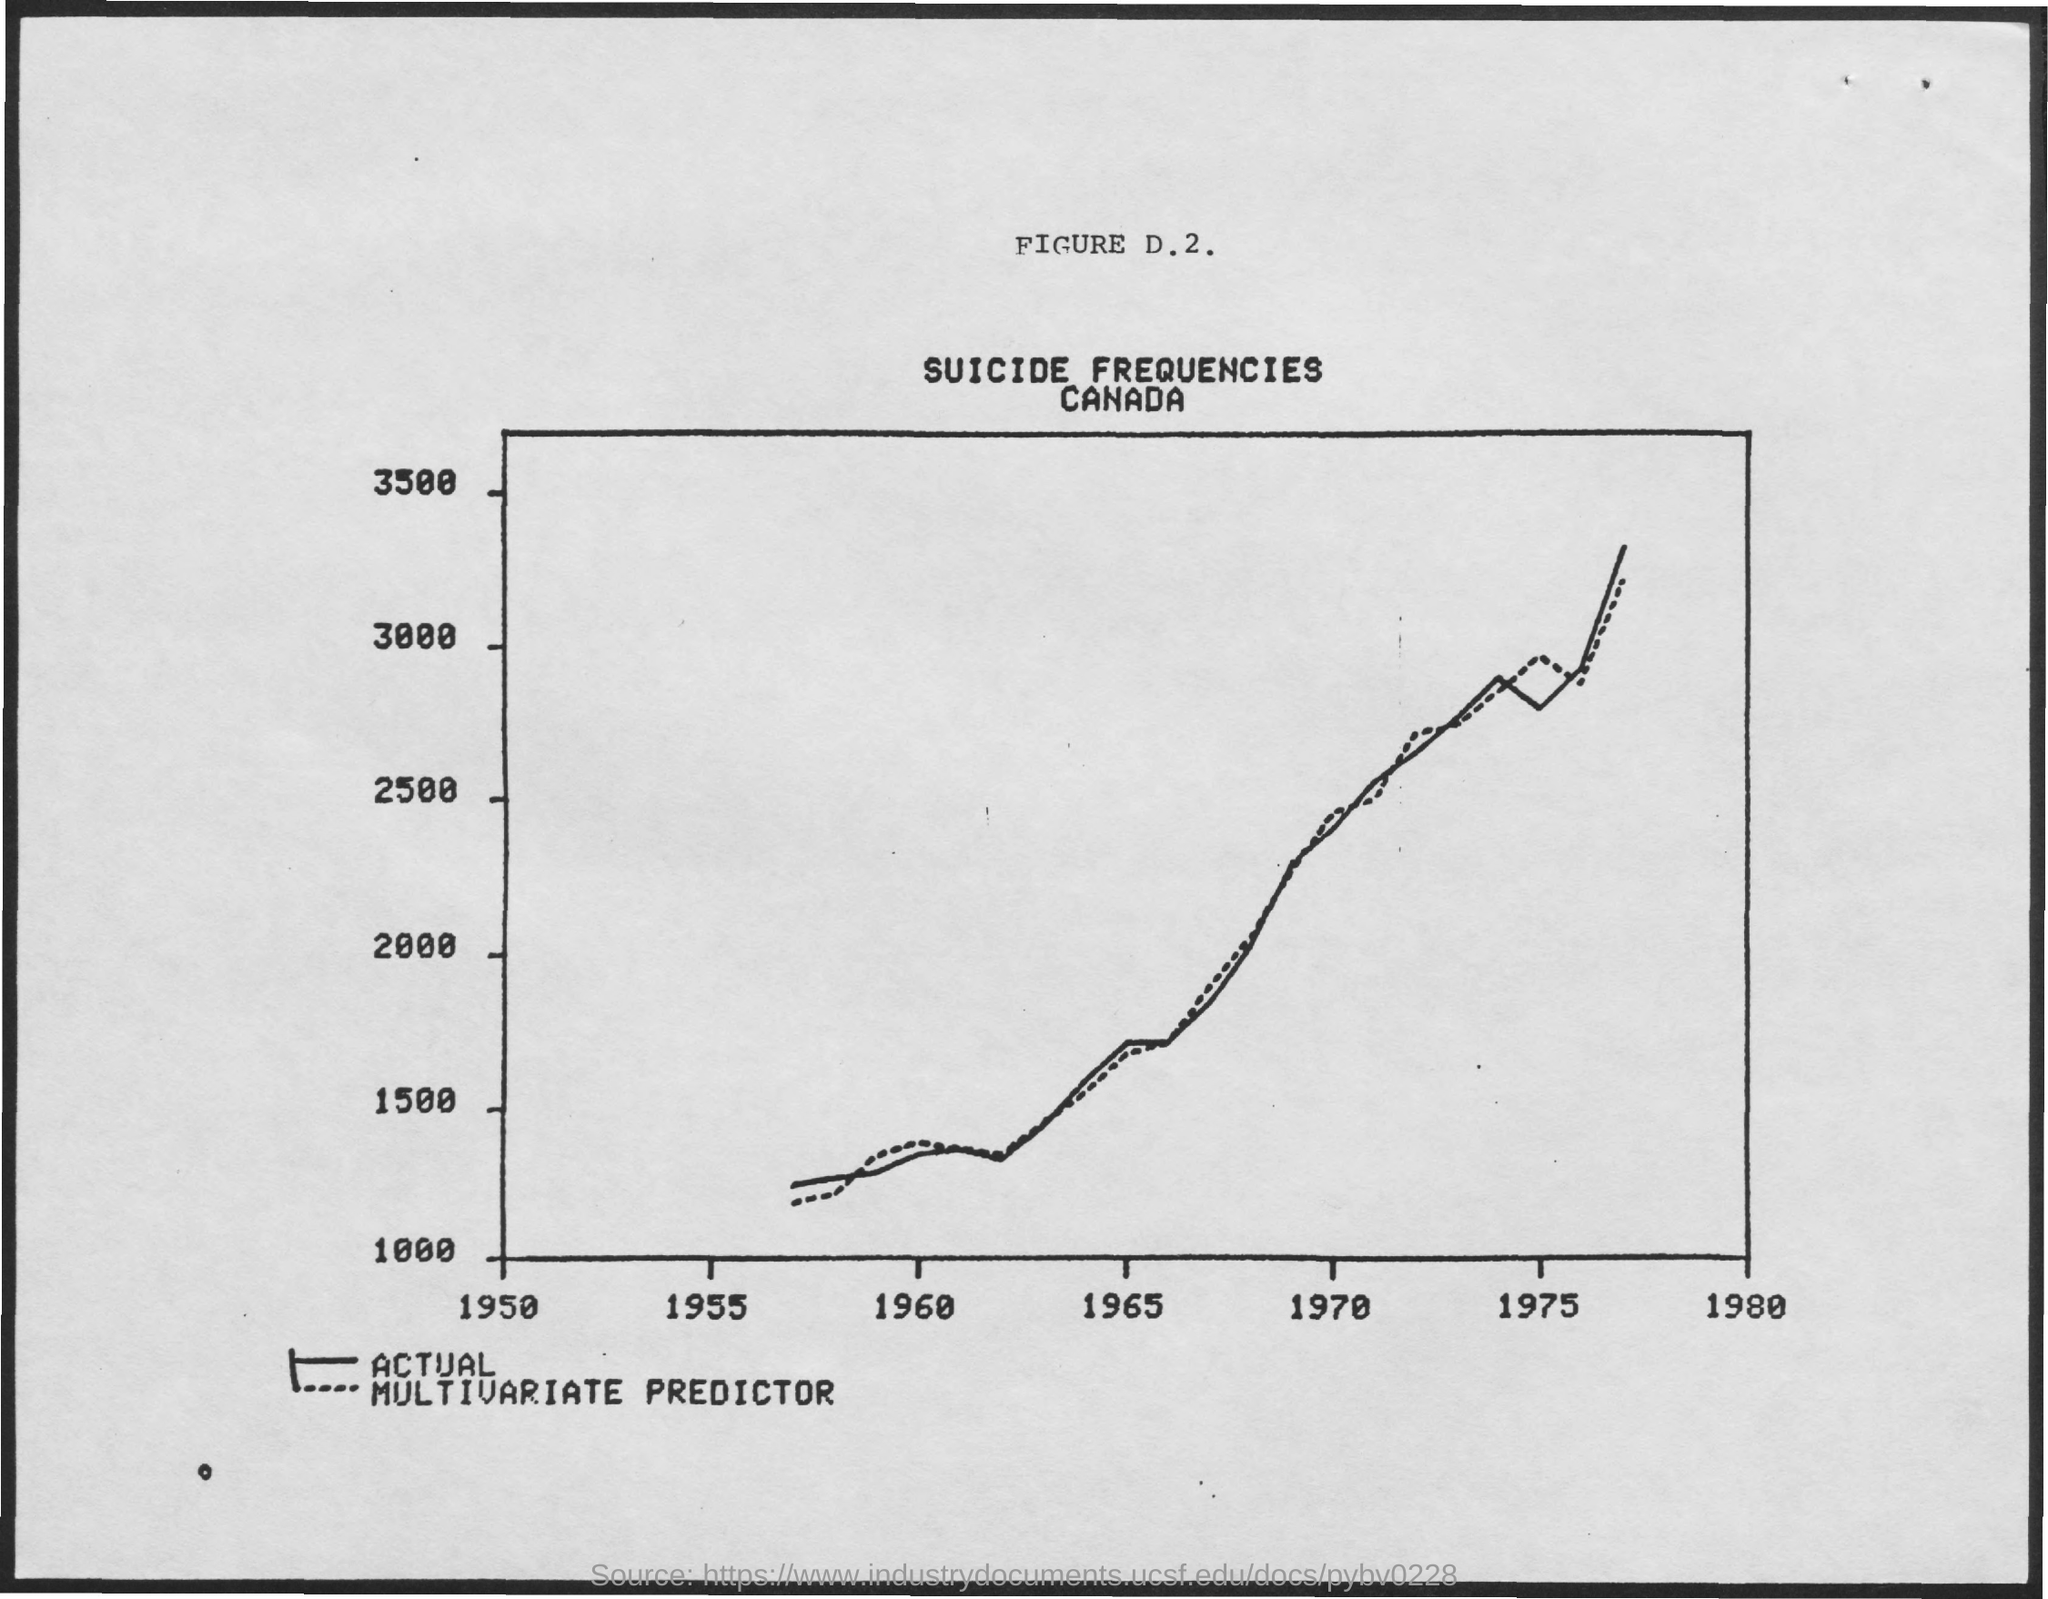List a handful of essential elements in this visual. The title of the graph is "Suicide Frequencies. The figure number mentioned is D.2. 